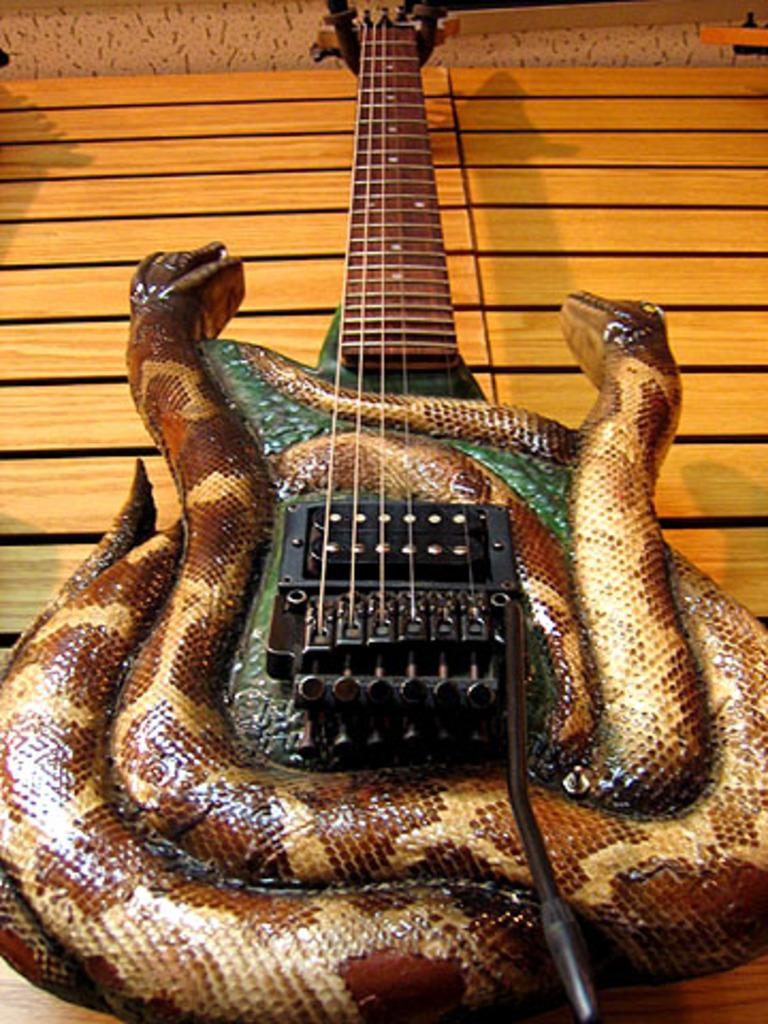What musical instrument is present in the image? There is a guitar in the image. What decorative elements are on the guitar? The guitar has snakes on it. Where is the guitar located in the image? The guitar is placed on a table. What type of patch is sewn onto the guitar in the image? There is no patch sewn onto the guitar in the image; it has snakes as decorative elements. 